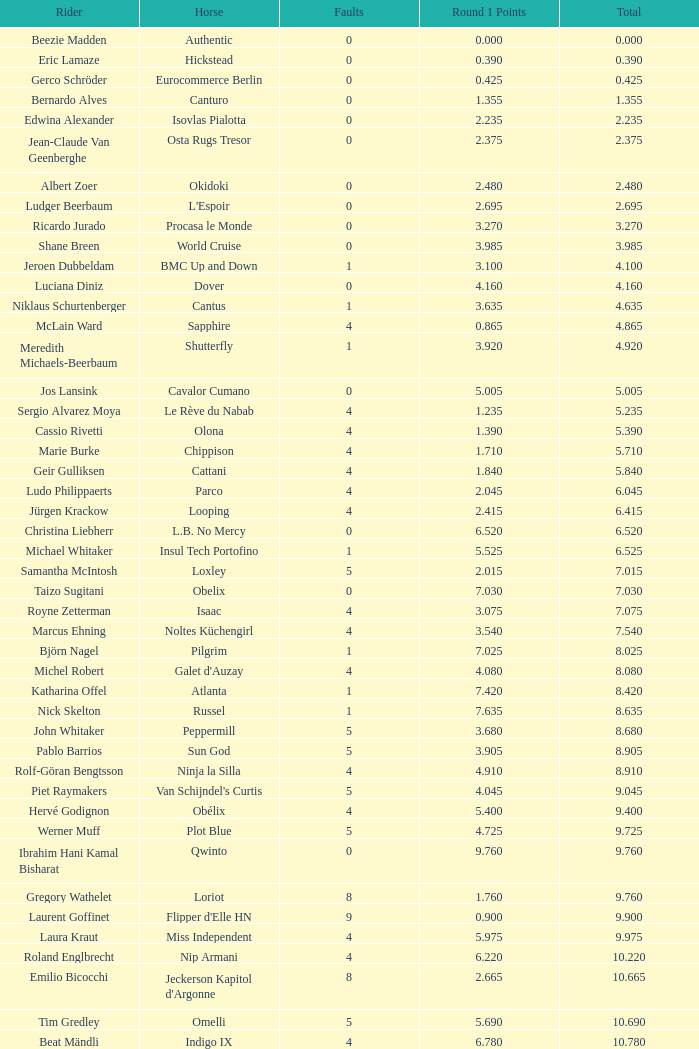Which rider had 7.465 points in round 1 and a total exceeding 16.615? Manuel Fernandez Saro. 